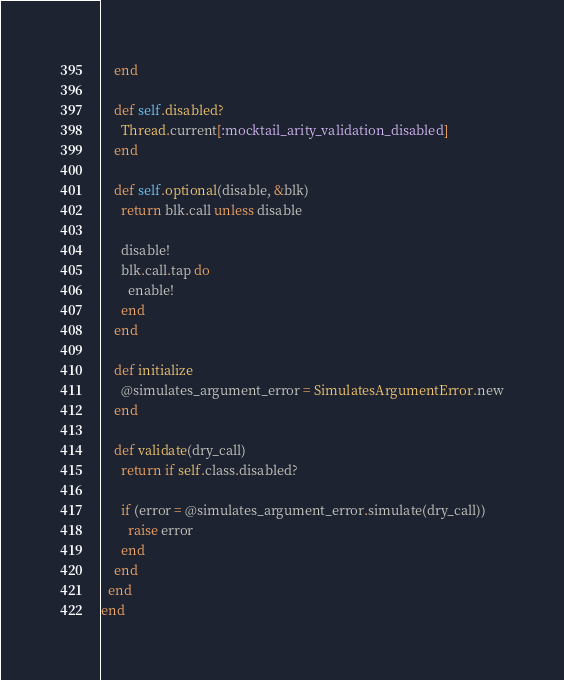Convert code to text. <code><loc_0><loc_0><loc_500><loc_500><_Ruby_>    end

    def self.disabled?
      Thread.current[:mocktail_arity_validation_disabled]
    end

    def self.optional(disable, &blk)
      return blk.call unless disable

      disable!
      blk.call.tap do
        enable!
      end
    end

    def initialize
      @simulates_argument_error = SimulatesArgumentError.new
    end

    def validate(dry_call)
      return if self.class.disabled?

      if (error = @simulates_argument_error.simulate(dry_call))
        raise error
      end
    end
  end
end
</code> 